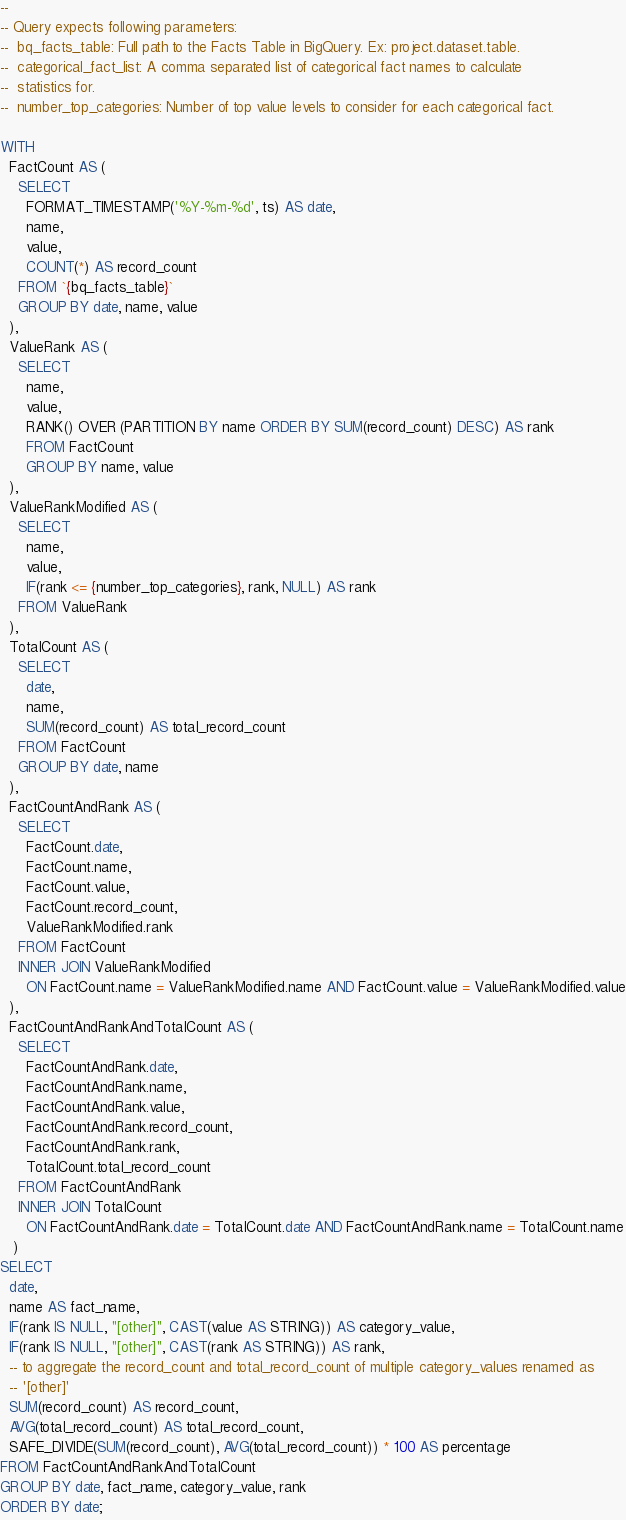<code> <loc_0><loc_0><loc_500><loc_500><_SQL_>--
-- Query expects following parameters:
--  bq_facts_table: Full path to the Facts Table in BigQuery. Ex: project.dataset.table.
--  categorical_fact_list: A comma separated list of categorical fact names to calculate
--  statistics for.
--  number_top_categories: Number of top value levels to consider for each categorical fact.

WITH
  FactCount AS (
    SELECT
      FORMAT_TIMESTAMP('%Y-%m-%d', ts) AS date,
      name,
      value,
      COUNT(*) AS record_count
    FROM `{bq_facts_table}`
    GROUP BY date, name, value
  ),
  ValueRank AS (
    SELECT
      name,
      value,
      RANK() OVER (PARTITION BY name ORDER BY SUM(record_count) DESC) AS rank
      FROM FactCount
      GROUP BY name, value
  ),
  ValueRankModified AS (
    SELECT
      name,
      value,
      IF(rank <= {number_top_categories}, rank, NULL) AS rank
    FROM ValueRank
  ),
  TotalCount AS (
    SELECT
      date,
      name,
      SUM(record_count) AS total_record_count
    FROM FactCount
    GROUP BY date, name
  ),
  FactCountAndRank AS (
    SELECT
      FactCount.date,
      FactCount.name,
      FactCount.value,
      FactCount.record_count,
      ValueRankModified.rank
    FROM FactCount
    INNER JOIN ValueRankModified
      ON FactCount.name = ValueRankModified.name AND FactCount.value = ValueRankModified.value
  ),
  FactCountAndRankAndTotalCount AS (
    SELECT
      FactCountAndRank.date,
      FactCountAndRank.name,
      FactCountAndRank.value,
      FactCountAndRank.record_count,
      FactCountAndRank.rank,
      TotalCount.total_record_count
    FROM FactCountAndRank
    INNER JOIN TotalCount
      ON FactCountAndRank.date = TotalCount.date AND FactCountAndRank.name = TotalCount.name
   )
SELECT
  date,
  name AS fact_name,
  IF(rank IS NULL, "[other]", CAST(value AS STRING)) AS category_value,
  IF(rank IS NULL, "[other]", CAST(rank AS STRING)) AS rank,
  -- to aggregate the record_count and total_record_count of multiple category_values renamed as
  -- '[other]'
  SUM(record_count) AS record_count,
  AVG(total_record_count) AS total_record_count,
  SAFE_DIVIDE(SUM(record_count), AVG(total_record_count)) * 100 AS percentage
FROM FactCountAndRankAndTotalCount
GROUP BY date, fact_name, category_value, rank
ORDER BY date;
</code> 